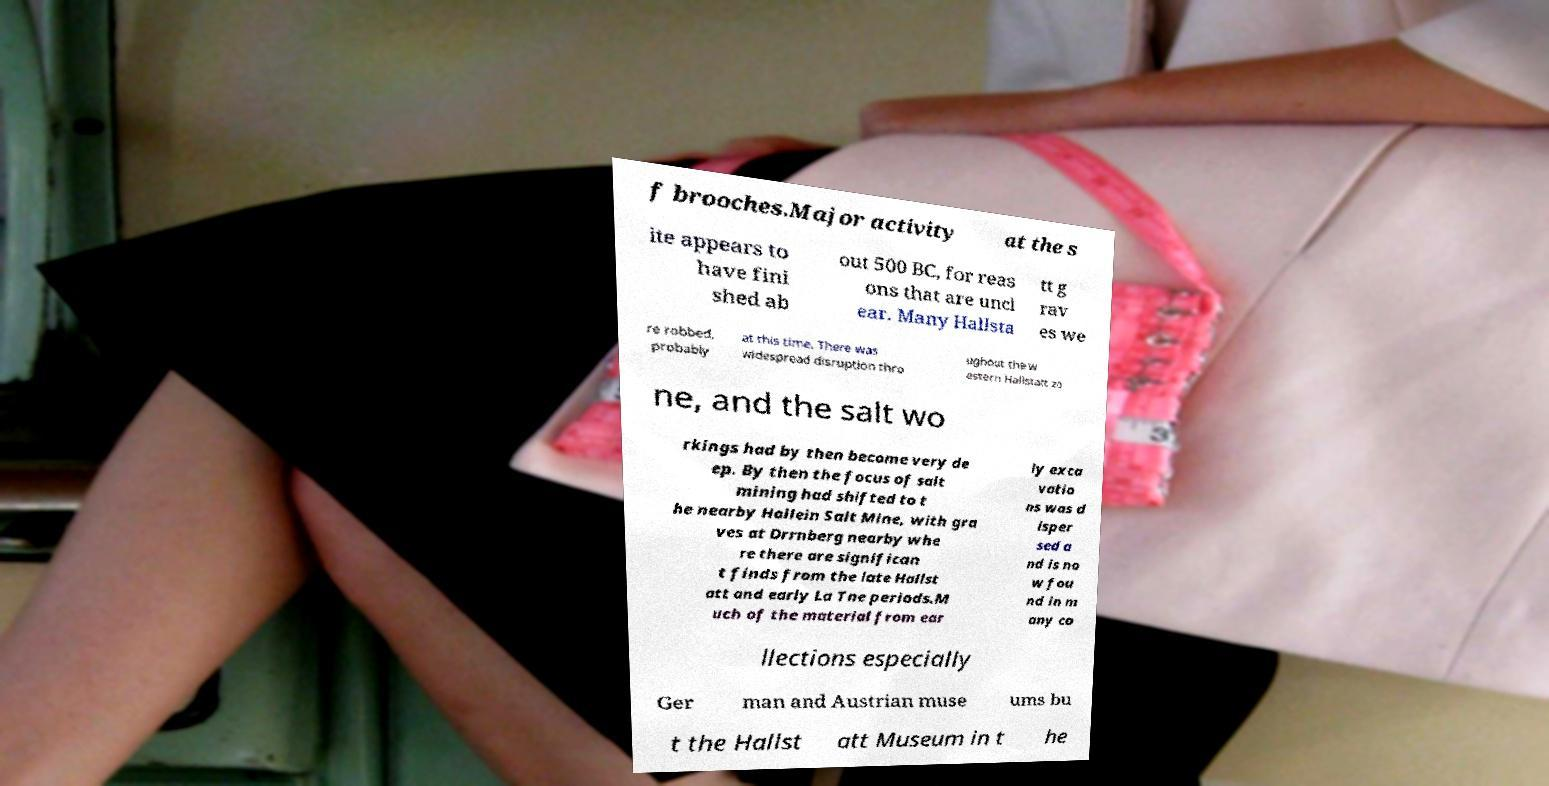I need the written content from this picture converted into text. Can you do that? f brooches.Major activity at the s ite appears to have fini shed ab out 500 BC, for reas ons that are uncl ear. Many Hallsta tt g rav es we re robbed, probably at this time. There was widespread disruption thro ughout the w estern Hallstatt zo ne, and the salt wo rkings had by then become very de ep. By then the focus of salt mining had shifted to t he nearby Hallein Salt Mine, with gra ves at Drrnberg nearby whe re there are significan t finds from the late Hallst att and early La Tne periods.M uch of the material from ear ly exca vatio ns was d isper sed a nd is no w fou nd in m any co llections especially Ger man and Austrian muse ums bu t the Hallst att Museum in t he 